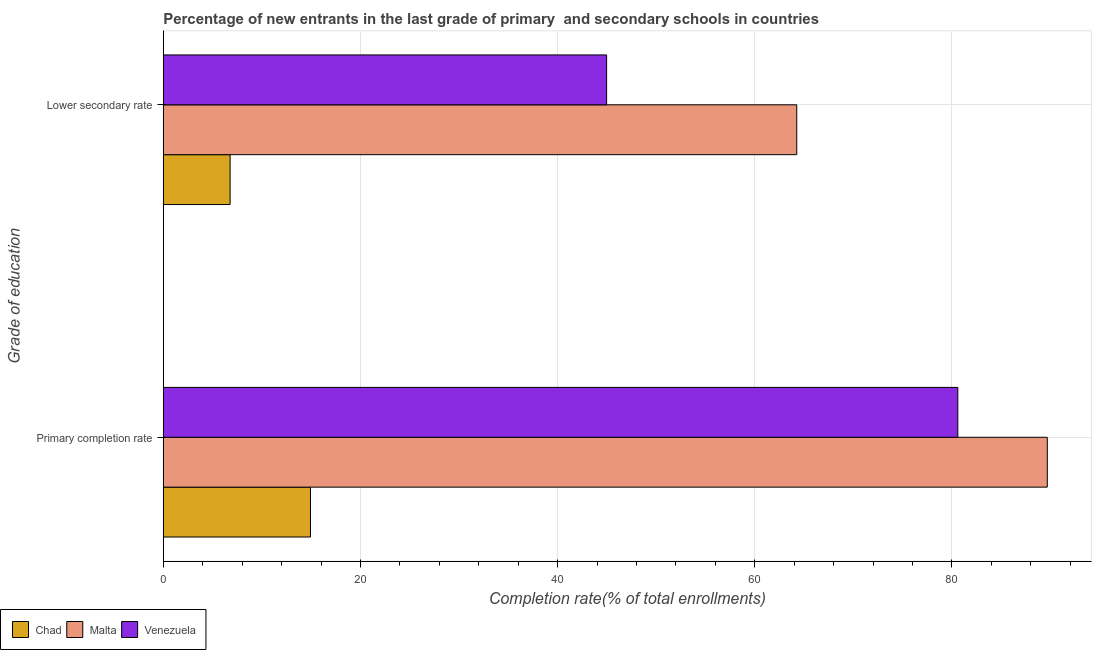Are the number of bars per tick equal to the number of legend labels?
Your answer should be very brief. Yes. Are the number of bars on each tick of the Y-axis equal?
Give a very brief answer. Yes. How many bars are there on the 1st tick from the top?
Give a very brief answer. 3. How many bars are there on the 1st tick from the bottom?
Your answer should be very brief. 3. What is the label of the 1st group of bars from the top?
Offer a very short reply. Lower secondary rate. What is the completion rate in secondary schools in Chad?
Your response must be concise. 6.78. Across all countries, what is the maximum completion rate in secondary schools?
Provide a succinct answer. 64.26. Across all countries, what is the minimum completion rate in primary schools?
Offer a very short reply. 14.93. In which country was the completion rate in secondary schools maximum?
Your response must be concise. Malta. In which country was the completion rate in primary schools minimum?
Give a very brief answer. Chad. What is the total completion rate in secondary schools in the graph?
Provide a succinct answer. 116.01. What is the difference between the completion rate in secondary schools in Chad and that in Venezuela?
Keep it short and to the point. -38.19. What is the difference between the completion rate in secondary schools in Malta and the completion rate in primary schools in Chad?
Make the answer very short. 49.32. What is the average completion rate in primary schools per country?
Keep it short and to the point. 61.73. What is the difference between the completion rate in primary schools and completion rate in secondary schools in Venezuela?
Your answer should be compact. 35.62. In how many countries, is the completion rate in secondary schools greater than 44 %?
Your answer should be very brief. 2. What is the ratio of the completion rate in secondary schools in Malta to that in Venezuela?
Give a very brief answer. 1.43. What does the 1st bar from the top in Primary completion rate represents?
Keep it short and to the point. Venezuela. What does the 3rd bar from the bottom in Primary completion rate represents?
Your response must be concise. Venezuela. How many bars are there?
Give a very brief answer. 6. How many countries are there in the graph?
Provide a succinct answer. 3. What is the difference between two consecutive major ticks on the X-axis?
Make the answer very short. 20. Are the values on the major ticks of X-axis written in scientific E-notation?
Give a very brief answer. No. Does the graph contain any zero values?
Offer a very short reply. No. Does the graph contain grids?
Your answer should be very brief. Yes. How are the legend labels stacked?
Provide a short and direct response. Horizontal. What is the title of the graph?
Your response must be concise. Percentage of new entrants in the last grade of primary  and secondary schools in countries. What is the label or title of the X-axis?
Give a very brief answer. Completion rate(% of total enrollments). What is the label or title of the Y-axis?
Provide a short and direct response. Grade of education. What is the Completion rate(% of total enrollments) of Chad in Primary completion rate?
Your answer should be compact. 14.93. What is the Completion rate(% of total enrollments) of Malta in Primary completion rate?
Keep it short and to the point. 89.67. What is the Completion rate(% of total enrollments) of Venezuela in Primary completion rate?
Give a very brief answer. 80.59. What is the Completion rate(% of total enrollments) of Chad in Lower secondary rate?
Offer a terse response. 6.78. What is the Completion rate(% of total enrollments) of Malta in Lower secondary rate?
Your answer should be compact. 64.26. What is the Completion rate(% of total enrollments) of Venezuela in Lower secondary rate?
Make the answer very short. 44.97. Across all Grade of education, what is the maximum Completion rate(% of total enrollments) of Chad?
Your response must be concise. 14.93. Across all Grade of education, what is the maximum Completion rate(% of total enrollments) of Malta?
Your response must be concise. 89.67. Across all Grade of education, what is the maximum Completion rate(% of total enrollments) of Venezuela?
Keep it short and to the point. 80.59. Across all Grade of education, what is the minimum Completion rate(% of total enrollments) in Chad?
Your answer should be compact. 6.78. Across all Grade of education, what is the minimum Completion rate(% of total enrollments) in Malta?
Offer a very short reply. 64.26. Across all Grade of education, what is the minimum Completion rate(% of total enrollments) in Venezuela?
Your answer should be compact. 44.97. What is the total Completion rate(% of total enrollments) in Chad in the graph?
Provide a succinct answer. 21.71. What is the total Completion rate(% of total enrollments) of Malta in the graph?
Offer a very short reply. 153.93. What is the total Completion rate(% of total enrollments) of Venezuela in the graph?
Offer a very short reply. 125.57. What is the difference between the Completion rate(% of total enrollments) in Chad in Primary completion rate and that in Lower secondary rate?
Your response must be concise. 8.15. What is the difference between the Completion rate(% of total enrollments) of Malta in Primary completion rate and that in Lower secondary rate?
Keep it short and to the point. 25.41. What is the difference between the Completion rate(% of total enrollments) of Venezuela in Primary completion rate and that in Lower secondary rate?
Provide a short and direct response. 35.62. What is the difference between the Completion rate(% of total enrollments) in Chad in Primary completion rate and the Completion rate(% of total enrollments) in Malta in Lower secondary rate?
Your answer should be very brief. -49.32. What is the difference between the Completion rate(% of total enrollments) in Chad in Primary completion rate and the Completion rate(% of total enrollments) in Venezuela in Lower secondary rate?
Provide a succinct answer. -30.04. What is the difference between the Completion rate(% of total enrollments) in Malta in Primary completion rate and the Completion rate(% of total enrollments) in Venezuela in Lower secondary rate?
Keep it short and to the point. 44.7. What is the average Completion rate(% of total enrollments) of Chad per Grade of education?
Keep it short and to the point. 10.86. What is the average Completion rate(% of total enrollments) of Malta per Grade of education?
Your response must be concise. 76.96. What is the average Completion rate(% of total enrollments) of Venezuela per Grade of education?
Provide a succinct answer. 62.78. What is the difference between the Completion rate(% of total enrollments) in Chad and Completion rate(% of total enrollments) in Malta in Primary completion rate?
Offer a very short reply. -74.74. What is the difference between the Completion rate(% of total enrollments) in Chad and Completion rate(% of total enrollments) in Venezuela in Primary completion rate?
Your answer should be compact. -65.66. What is the difference between the Completion rate(% of total enrollments) of Malta and Completion rate(% of total enrollments) of Venezuela in Primary completion rate?
Give a very brief answer. 9.08. What is the difference between the Completion rate(% of total enrollments) in Chad and Completion rate(% of total enrollments) in Malta in Lower secondary rate?
Give a very brief answer. -57.48. What is the difference between the Completion rate(% of total enrollments) in Chad and Completion rate(% of total enrollments) in Venezuela in Lower secondary rate?
Your answer should be very brief. -38.19. What is the difference between the Completion rate(% of total enrollments) in Malta and Completion rate(% of total enrollments) in Venezuela in Lower secondary rate?
Your answer should be compact. 19.29. What is the ratio of the Completion rate(% of total enrollments) of Chad in Primary completion rate to that in Lower secondary rate?
Your answer should be very brief. 2.2. What is the ratio of the Completion rate(% of total enrollments) in Malta in Primary completion rate to that in Lower secondary rate?
Your answer should be compact. 1.4. What is the ratio of the Completion rate(% of total enrollments) of Venezuela in Primary completion rate to that in Lower secondary rate?
Your answer should be very brief. 1.79. What is the difference between the highest and the second highest Completion rate(% of total enrollments) of Chad?
Keep it short and to the point. 8.15. What is the difference between the highest and the second highest Completion rate(% of total enrollments) in Malta?
Your answer should be compact. 25.41. What is the difference between the highest and the second highest Completion rate(% of total enrollments) of Venezuela?
Keep it short and to the point. 35.62. What is the difference between the highest and the lowest Completion rate(% of total enrollments) of Chad?
Keep it short and to the point. 8.15. What is the difference between the highest and the lowest Completion rate(% of total enrollments) in Malta?
Keep it short and to the point. 25.41. What is the difference between the highest and the lowest Completion rate(% of total enrollments) in Venezuela?
Provide a succinct answer. 35.62. 